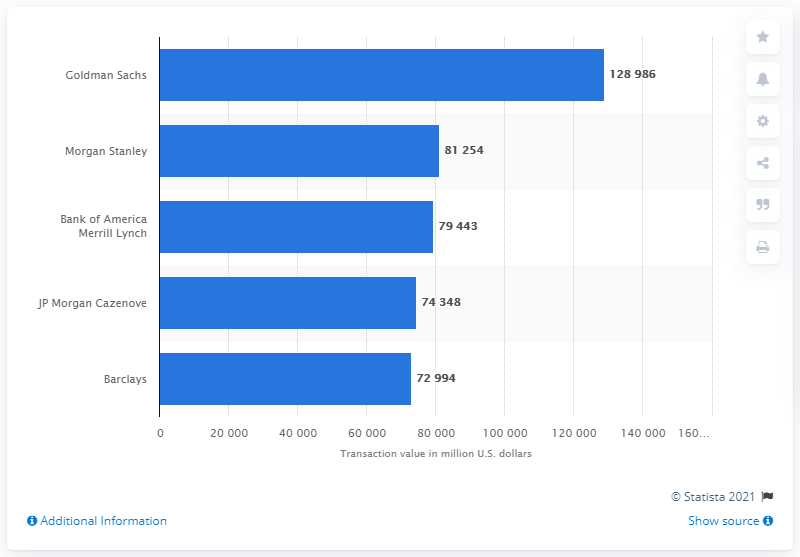Specify some key components in this picture. According to a ranking in 2016, Goldman Sachs was identified as the top financial advisory firm. 